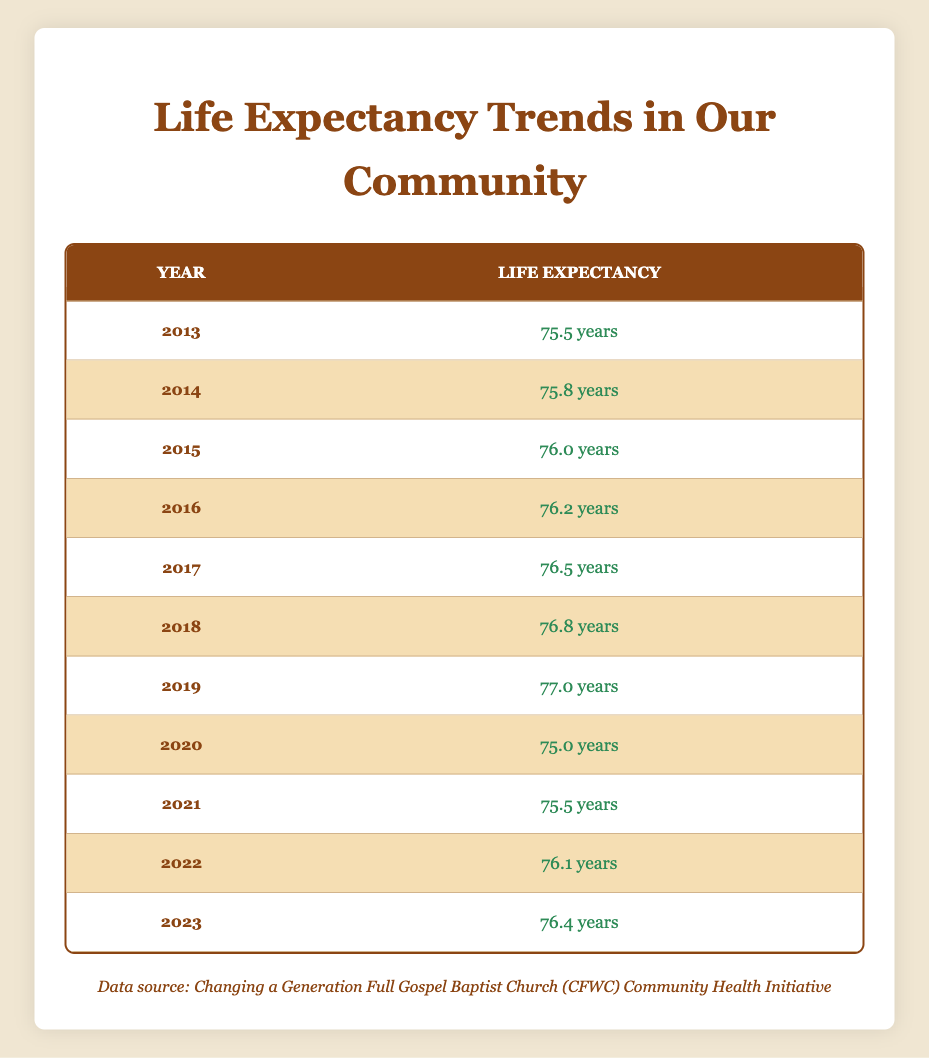What was the life expectancy for the African American demographic in 2019? According to the table, the life expectancy for the African American demographic in 2019 is listed as 77.0 years.
Answer: 77.0 years What was the lowest life expectancy recorded in this data? By examining the table, the lowest life expectancy recorded is 75.0 years, which was in the year 2020.
Answer: 75.0 years In which year did the life expectancy for the African American demographic reach its highest point? The highest life expectancy recorded in the table is 77.0 years, which occurred in 2019.
Answer: 2019 What is the difference in life expectancy between 2013 and 2023? The life expectancy in 2013 was 75.5 years, and in 2023 it was 76.4 years. The difference is 76.4 - 75.5 = 0.9 years.
Answer: 0.9 years Is the life expectancy in 2022 higher than that in 2021? Yes, life expectancy in 2022 (76.1 years) is higher than in 2021 (75.5 years).
Answer: Yes What is the average life expectancy over the last decade from 2013 to 2023? To calculate the average, we sum the life expectancies from 2013 to 2023: 75.5 + 75.8 + 76.0 + 76.2 + 76.5 + 76.8 + 77.0 + 75.0 + 75.5 + 76.1 + 76.4 = 839.4. There are 11 data points, so the average is 839.4 / 11 = 76.3 years.
Answer: 76.3 years Did the life expectancy decrease in any year from 2013 to 2023? Yes, there was a decrease in life expectancy from 2019 to 2020, going from 77.0 years to 75.0 years.
Answer: Yes How much did life expectancy increase from 2013 to 2019? From 2013 (75.5 years) to 2019 (77.0 years), it increased by 77.0 - 75.5 = 1.5 years.
Answer: 1.5 years In which year was the increase in life expectancy the most significant? The greatest increase occurred from 2015 to 2016, where it increased from 76.0 years to 76.2 years, an increase of 0.2 years.
Answer: 2015 to 2016 